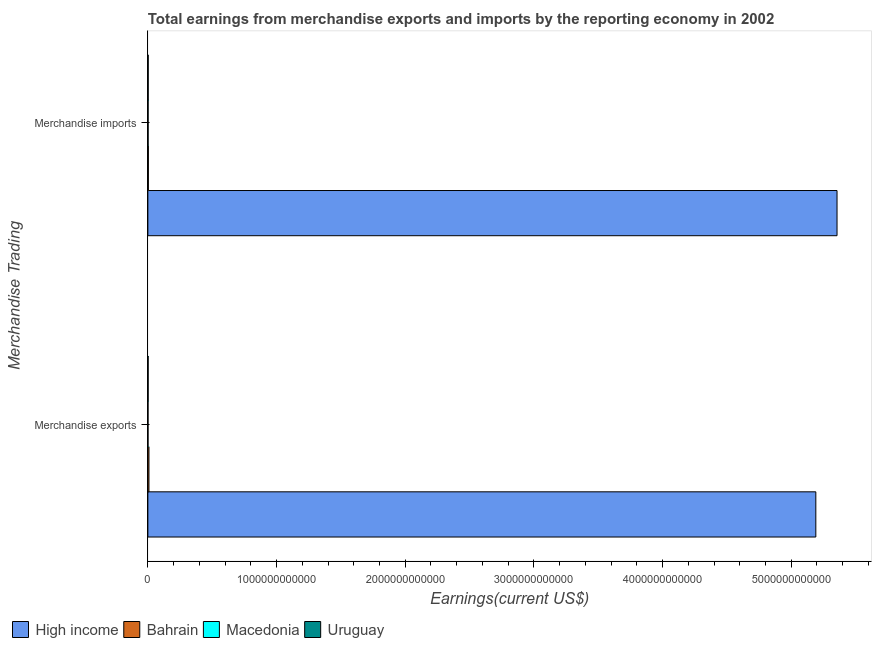How many bars are there on the 2nd tick from the top?
Provide a succinct answer. 4. What is the label of the 1st group of bars from the top?
Give a very brief answer. Merchandise imports. What is the earnings from merchandise exports in Uruguay?
Ensure brevity in your answer.  2.18e+09. Across all countries, what is the maximum earnings from merchandise exports?
Keep it short and to the point. 5.19e+12. Across all countries, what is the minimum earnings from merchandise imports?
Make the answer very short. 2.00e+09. In which country was the earnings from merchandise imports maximum?
Your response must be concise. High income. In which country was the earnings from merchandise exports minimum?
Your response must be concise. Macedonia. What is the total earnings from merchandise imports in the graph?
Your response must be concise. 5.36e+12. What is the difference between the earnings from merchandise imports in Bahrain and that in Macedonia?
Your answer should be compact. 1.85e+09. What is the difference between the earnings from merchandise imports in Uruguay and the earnings from merchandise exports in Macedonia?
Offer a terse response. 1.47e+09. What is the average earnings from merchandise exports per country?
Provide a succinct answer. 1.30e+12. What is the difference between the earnings from merchandise exports and earnings from merchandise imports in Bahrain?
Give a very brief answer. 4.60e+09. What is the ratio of the earnings from merchandise exports in Bahrain to that in High income?
Offer a terse response. 0. What does the 2nd bar from the top in Merchandise imports represents?
Keep it short and to the point. Macedonia. What does the 3rd bar from the bottom in Merchandise exports represents?
Offer a very short reply. Macedonia. How many bars are there?
Make the answer very short. 8. How many countries are there in the graph?
Your answer should be very brief. 4. What is the difference between two consecutive major ticks on the X-axis?
Your answer should be compact. 1.00e+12. Are the values on the major ticks of X-axis written in scientific E-notation?
Offer a terse response. No. Does the graph contain any zero values?
Offer a terse response. No. Does the graph contain grids?
Your response must be concise. No. Where does the legend appear in the graph?
Provide a succinct answer. Bottom left. What is the title of the graph?
Keep it short and to the point. Total earnings from merchandise exports and imports by the reporting economy in 2002. What is the label or title of the X-axis?
Ensure brevity in your answer.  Earnings(current US$). What is the label or title of the Y-axis?
Ensure brevity in your answer.  Merchandise Trading. What is the Earnings(current US$) in High income in Merchandise exports?
Provide a succinct answer. 5.19e+12. What is the Earnings(current US$) in Bahrain in Merchandise exports?
Your answer should be compact. 8.44e+09. What is the Earnings(current US$) in Macedonia in Merchandise exports?
Your response must be concise. 1.12e+09. What is the Earnings(current US$) in Uruguay in Merchandise exports?
Your answer should be very brief. 2.18e+09. What is the Earnings(current US$) of High income in Merchandise imports?
Offer a very short reply. 5.36e+12. What is the Earnings(current US$) in Bahrain in Merchandise imports?
Ensure brevity in your answer.  3.84e+09. What is the Earnings(current US$) of Macedonia in Merchandise imports?
Offer a terse response. 2.00e+09. What is the Earnings(current US$) of Uruguay in Merchandise imports?
Make the answer very short. 2.58e+09. Across all Merchandise Trading, what is the maximum Earnings(current US$) in High income?
Your answer should be compact. 5.36e+12. Across all Merchandise Trading, what is the maximum Earnings(current US$) of Bahrain?
Offer a terse response. 8.44e+09. Across all Merchandise Trading, what is the maximum Earnings(current US$) of Macedonia?
Provide a succinct answer. 2.00e+09. Across all Merchandise Trading, what is the maximum Earnings(current US$) in Uruguay?
Provide a succinct answer. 2.58e+09. Across all Merchandise Trading, what is the minimum Earnings(current US$) in High income?
Keep it short and to the point. 5.19e+12. Across all Merchandise Trading, what is the minimum Earnings(current US$) of Bahrain?
Give a very brief answer. 3.84e+09. Across all Merchandise Trading, what is the minimum Earnings(current US$) in Macedonia?
Provide a succinct answer. 1.12e+09. Across all Merchandise Trading, what is the minimum Earnings(current US$) of Uruguay?
Offer a terse response. 2.18e+09. What is the total Earnings(current US$) of High income in the graph?
Provide a short and direct response. 1.05e+13. What is the total Earnings(current US$) in Bahrain in the graph?
Ensure brevity in your answer.  1.23e+1. What is the total Earnings(current US$) of Macedonia in the graph?
Your answer should be very brief. 3.11e+09. What is the total Earnings(current US$) in Uruguay in the graph?
Provide a succinct answer. 4.76e+09. What is the difference between the Earnings(current US$) of High income in Merchandise exports and that in Merchandise imports?
Ensure brevity in your answer.  -1.65e+11. What is the difference between the Earnings(current US$) of Bahrain in Merchandise exports and that in Merchandise imports?
Keep it short and to the point. 4.60e+09. What is the difference between the Earnings(current US$) of Macedonia in Merchandise exports and that in Merchandise imports?
Offer a very short reply. -8.80e+08. What is the difference between the Earnings(current US$) in Uruguay in Merchandise exports and that in Merchandise imports?
Your answer should be very brief. -4.01e+08. What is the difference between the Earnings(current US$) in High income in Merchandise exports and the Earnings(current US$) in Bahrain in Merchandise imports?
Ensure brevity in your answer.  5.19e+12. What is the difference between the Earnings(current US$) in High income in Merchandise exports and the Earnings(current US$) in Macedonia in Merchandise imports?
Keep it short and to the point. 5.19e+12. What is the difference between the Earnings(current US$) of High income in Merchandise exports and the Earnings(current US$) of Uruguay in Merchandise imports?
Provide a short and direct response. 5.19e+12. What is the difference between the Earnings(current US$) of Bahrain in Merchandise exports and the Earnings(current US$) of Macedonia in Merchandise imports?
Your answer should be very brief. 6.44e+09. What is the difference between the Earnings(current US$) of Bahrain in Merchandise exports and the Earnings(current US$) of Uruguay in Merchandise imports?
Give a very brief answer. 5.86e+09. What is the difference between the Earnings(current US$) of Macedonia in Merchandise exports and the Earnings(current US$) of Uruguay in Merchandise imports?
Provide a succinct answer. -1.47e+09. What is the average Earnings(current US$) of High income per Merchandise Trading?
Your response must be concise. 5.27e+12. What is the average Earnings(current US$) in Bahrain per Merchandise Trading?
Give a very brief answer. 6.14e+09. What is the average Earnings(current US$) in Macedonia per Merchandise Trading?
Make the answer very short. 1.56e+09. What is the average Earnings(current US$) in Uruguay per Merchandise Trading?
Keep it short and to the point. 2.38e+09. What is the difference between the Earnings(current US$) of High income and Earnings(current US$) of Bahrain in Merchandise exports?
Offer a terse response. 5.18e+12. What is the difference between the Earnings(current US$) of High income and Earnings(current US$) of Macedonia in Merchandise exports?
Offer a terse response. 5.19e+12. What is the difference between the Earnings(current US$) of High income and Earnings(current US$) of Uruguay in Merchandise exports?
Give a very brief answer. 5.19e+12. What is the difference between the Earnings(current US$) of Bahrain and Earnings(current US$) of Macedonia in Merchandise exports?
Give a very brief answer. 7.32e+09. What is the difference between the Earnings(current US$) of Bahrain and Earnings(current US$) of Uruguay in Merchandise exports?
Your answer should be very brief. 6.26e+09. What is the difference between the Earnings(current US$) of Macedonia and Earnings(current US$) of Uruguay in Merchandise exports?
Give a very brief answer. -1.07e+09. What is the difference between the Earnings(current US$) in High income and Earnings(current US$) in Bahrain in Merchandise imports?
Make the answer very short. 5.35e+12. What is the difference between the Earnings(current US$) in High income and Earnings(current US$) in Macedonia in Merchandise imports?
Your answer should be very brief. 5.35e+12. What is the difference between the Earnings(current US$) of High income and Earnings(current US$) of Uruguay in Merchandise imports?
Make the answer very short. 5.35e+12. What is the difference between the Earnings(current US$) in Bahrain and Earnings(current US$) in Macedonia in Merchandise imports?
Your answer should be very brief. 1.85e+09. What is the difference between the Earnings(current US$) in Bahrain and Earnings(current US$) in Uruguay in Merchandise imports?
Keep it short and to the point. 1.26e+09. What is the difference between the Earnings(current US$) in Macedonia and Earnings(current US$) in Uruguay in Merchandise imports?
Make the answer very short. -5.87e+08. What is the ratio of the Earnings(current US$) in High income in Merchandise exports to that in Merchandise imports?
Offer a terse response. 0.97. What is the ratio of the Earnings(current US$) of Bahrain in Merchandise exports to that in Merchandise imports?
Provide a short and direct response. 2.2. What is the ratio of the Earnings(current US$) in Macedonia in Merchandise exports to that in Merchandise imports?
Your answer should be compact. 0.56. What is the ratio of the Earnings(current US$) of Uruguay in Merchandise exports to that in Merchandise imports?
Provide a short and direct response. 0.84. What is the difference between the highest and the second highest Earnings(current US$) of High income?
Your answer should be very brief. 1.65e+11. What is the difference between the highest and the second highest Earnings(current US$) of Bahrain?
Your response must be concise. 4.60e+09. What is the difference between the highest and the second highest Earnings(current US$) of Macedonia?
Your response must be concise. 8.80e+08. What is the difference between the highest and the second highest Earnings(current US$) in Uruguay?
Ensure brevity in your answer.  4.01e+08. What is the difference between the highest and the lowest Earnings(current US$) of High income?
Make the answer very short. 1.65e+11. What is the difference between the highest and the lowest Earnings(current US$) of Bahrain?
Your answer should be compact. 4.60e+09. What is the difference between the highest and the lowest Earnings(current US$) of Macedonia?
Your answer should be compact. 8.80e+08. What is the difference between the highest and the lowest Earnings(current US$) in Uruguay?
Your answer should be very brief. 4.01e+08. 